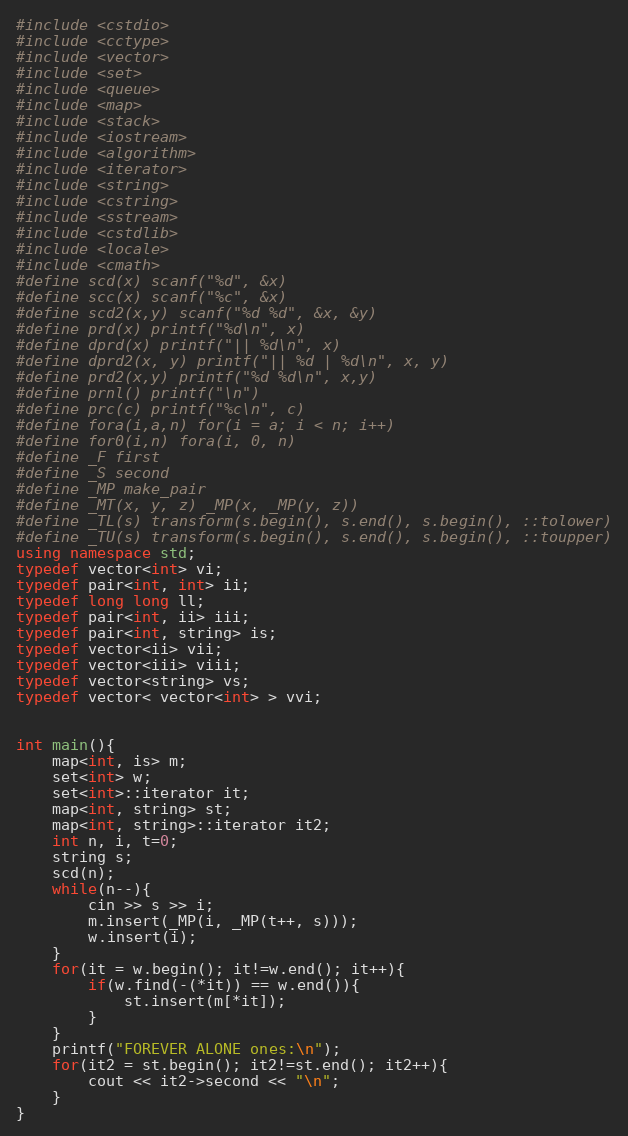Convert code to text. <code><loc_0><loc_0><loc_500><loc_500><_C++_>#include <cstdio>
#include <cctype>
#include <vector>
#include <set>
#include <queue>
#include <map>
#include <stack>
#include <iostream>
#include <algorithm>
#include <iterator>
#include <string>
#include <cstring>
#include <sstream>
#include <cstdlib>
#include <locale>
#include <cmath>
#define scd(x) scanf("%d", &x)
#define scc(x) scanf("%c", &x)
#define scd2(x,y) scanf("%d %d", &x, &y)
#define prd(x) printf("%d\n", x)
#define dprd(x) printf("|| %d\n", x)
#define dprd2(x, y) printf("|| %d | %d\n", x, y)
#define prd2(x,y) printf("%d %d\n", x,y)
#define prnl() printf("\n")
#define prc(c) printf("%c\n", c)
#define fora(i,a,n) for(i = a; i < n; i++)
#define for0(i,n) fora(i, 0, n)
#define _F first
#define _S second
#define _MP make_pair
#define _MT(x, y, z) _MP(x, _MP(y, z))
#define _TL(s) transform(s.begin(), s.end(), s.begin(), ::tolower)
#define _TU(s) transform(s.begin(), s.end(), s.begin(), ::toupper)
using namespace std;
typedef vector<int> vi;
typedef pair<int, int> ii;
typedef long long ll;
typedef pair<int, ii> iii;
typedef pair<int, string> is;
typedef vector<ii> vii;
typedef vector<iii> viii;
typedef vector<string> vs;
typedef vector< vector<int> > vvi;


int main(){
	map<int, is> m;
	set<int> w;
	set<int>::iterator it;
	map<int, string> st;
	map<int, string>::iterator it2;
	int n, i, t=0;
	string s;
	scd(n);
	while(n--){
		cin >> s >> i;
		m.insert(_MP(i, _MP(t++, s)));
		w.insert(i);
	}
	for(it = w.begin(); it!=w.end(); it++){
		if(w.find(-(*it)) == w.end()){
			st.insert(m[*it]);
		}
	}
	printf("FOREVER ALONE ones:\n");
	for(it2 = st.begin(); it2!=st.end(); it2++){
		cout << it2->second << "\n";
	}
}







</code> 